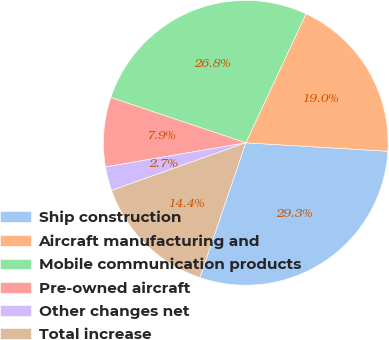Convert chart. <chart><loc_0><loc_0><loc_500><loc_500><pie_chart><fcel>Ship construction<fcel>Aircraft manufacturing and<fcel>Mobile communication products<fcel>Pre-owned aircraft<fcel>Other changes net<fcel>Total increase<nl><fcel>29.27%<fcel>18.99%<fcel>26.8%<fcel>7.87%<fcel>2.71%<fcel>14.36%<nl></chart> 